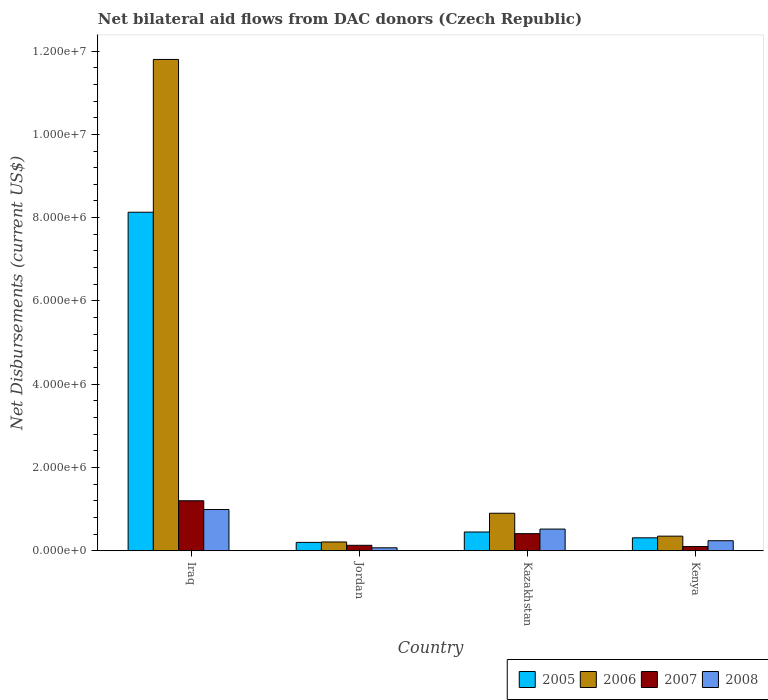How many different coloured bars are there?
Provide a short and direct response. 4. How many bars are there on the 2nd tick from the right?
Offer a terse response. 4. What is the label of the 2nd group of bars from the left?
Your response must be concise. Jordan. What is the net bilateral aid flows in 2007 in Iraq?
Offer a very short reply. 1.20e+06. Across all countries, what is the maximum net bilateral aid flows in 2007?
Offer a very short reply. 1.20e+06. In which country was the net bilateral aid flows in 2005 maximum?
Provide a succinct answer. Iraq. In which country was the net bilateral aid flows in 2005 minimum?
Make the answer very short. Jordan. What is the total net bilateral aid flows in 2007 in the graph?
Keep it short and to the point. 1.84e+06. What is the difference between the net bilateral aid flows in 2007 in Kazakhstan and that in Kenya?
Your response must be concise. 3.10e+05. What is the difference between the net bilateral aid flows in 2005 in Iraq and the net bilateral aid flows in 2006 in Kazakhstan?
Your answer should be very brief. 7.23e+06. What is the average net bilateral aid flows in 2005 per country?
Ensure brevity in your answer.  2.27e+06. What is the ratio of the net bilateral aid flows in 2006 in Jordan to that in Kenya?
Your answer should be compact. 0.6. Is the net bilateral aid flows in 2006 in Iraq less than that in Kazakhstan?
Provide a short and direct response. No. Is the difference between the net bilateral aid flows in 2005 in Iraq and Jordan greater than the difference between the net bilateral aid flows in 2008 in Iraq and Jordan?
Your response must be concise. Yes. What is the difference between the highest and the second highest net bilateral aid flows in 2005?
Your response must be concise. 7.82e+06. What is the difference between the highest and the lowest net bilateral aid flows in 2008?
Keep it short and to the point. 9.20e+05. Is it the case that in every country, the sum of the net bilateral aid flows in 2006 and net bilateral aid flows in 2007 is greater than the sum of net bilateral aid flows in 2008 and net bilateral aid flows in 2005?
Give a very brief answer. No. What does the 3rd bar from the left in Iraq represents?
Your answer should be very brief. 2007. Is it the case that in every country, the sum of the net bilateral aid flows in 2005 and net bilateral aid flows in 2008 is greater than the net bilateral aid flows in 2006?
Provide a short and direct response. No. How many bars are there?
Provide a succinct answer. 16. What is the difference between two consecutive major ticks on the Y-axis?
Keep it short and to the point. 2.00e+06. Are the values on the major ticks of Y-axis written in scientific E-notation?
Keep it short and to the point. Yes. Does the graph contain grids?
Give a very brief answer. No. How many legend labels are there?
Provide a short and direct response. 4. How are the legend labels stacked?
Provide a succinct answer. Horizontal. What is the title of the graph?
Your answer should be compact. Net bilateral aid flows from DAC donors (Czech Republic). What is the label or title of the X-axis?
Your response must be concise. Country. What is the label or title of the Y-axis?
Your answer should be very brief. Net Disbursements (current US$). What is the Net Disbursements (current US$) in 2005 in Iraq?
Your response must be concise. 8.13e+06. What is the Net Disbursements (current US$) of 2006 in Iraq?
Your response must be concise. 1.18e+07. What is the Net Disbursements (current US$) of 2007 in Iraq?
Offer a terse response. 1.20e+06. What is the Net Disbursements (current US$) of 2008 in Iraq?
Your answer should be very brief. 9.90e+05. What is the Net Disbursements (current US$) in 2006 in Jordan?
Your answer should be compact. 2.10e+05. What is the Net Disbursements (current US$) of 2007 in Jordan?
Your response must be concise. 1.30e+05. What is the Net Disbursements (current US$) in 2005 in Kazakhstan?
Offer a very short reply. 4.50e+05. What is the Net Disbursements (current US$) of 2006 in Kazakhstan?
Your answer should be very brief. 9.00e+05. What is the Net Disbursements (current US$) of 2007 in Kazakhstan?
Make the answer very short. 4.10e+05. What is the Net Disbursements (current US$) of 2008 in Kazakhstan?
Provide a short and direct response. 5.20e+05. What is the Net Disbursements (current US$) of 2005 in Kenya?
Offer a terse response. 3.10e+05. Across all countries, what is the maximum Net Disbursements (current US$) of 2005?
Ensure brevity in your answer.  8.13e+06. Across all countries, what is the maximum Net Disbursements (current US$) in 2006?
Your answer should be compact. 1.18e+07. Across all countries, what is the maximum Net Disbursements (current US$) of 2007?
Offer a terse response. 1.20e+06. Across all countries, what is the maximum Net Disbursements (current US$) of 2008?
Your response must be concise. 9.90e+05. Across all countries, what is the minimum Net Disbursements (current US$) in 2005?
Your response must be concise. 2.00e+05. Across all countries, what is the minimum Net Disbursements (current US$) of 2006?
Ensure brevity in your answer.  2.10e+05. Across all countries, what is the minimum Net Disbursements (current US$) in 2007?
Your answer should be compact. 1.00e+05. What is the total Net Disbursements (current US$) in 2005 in the graph?
Offer a very short reply. 9.09e+06. What is the total Net Disbursements (current US$) in 2006 in the graph?
Ensure brevity in your answer.  1.33e+07. What is the total Net Disbursements (current US$) of 2007 in the graph?
Give a very brief answer. 1.84e+06. What is the total Net Disbursements (current US$) in 2008 in the graph?
Make the answer very short. 1.82e+06. What is the difference between the Net Disbursements (current US$) in 2005 in Iraq and that in Jordan?
Give a very brief answer. 7.93e+06. What is the difference between the Net Disbursements (current US$) in 2006 in Iraq and that in Jordan?
Ensure brevity in your answer.  1.16e+07. What is the difference between the Net Disbursements (current US$) in 2007 in Iraq and that in Jordan?
Your answer should be very brief. 1.07e+06. What is the difference between the Net Disbursements (current US$) of 2008 in Iraq and that in Jordan?
Ensure brevity in your answer.  9.20e+05. What is the difference between the Net Disbursements (current US$) in 2005 in Iraq and that in Kazakhstan?
Your answer should be very brief. 7.68e+06. What is the difference between the Net Disbursements (current US$) in 2006 in Iraq and that in Kazakhstan?
Provide a short and direct response. 1.09e+07. What is the difference between the Net Disbursements (current US$) of 2007 in Iraq and that in Kazakhstan?
Offer a terse response. 7.90e+05. What is the difference between the Net Disbursements (current US$) in 2005 in Iraq and that in Kenya?
Make the answer very short. 7.82e+06. What is the difference between the Net Disbursements (current US$) of 2006 in Iraq and that in Kenya?
Your answer should be very brief. 1.14e+07. What is the difference between the Net Disbursements (current US$) in 2007 in Iraq and that in Kenya?
Provide a short and direct response. 1.10e+06. What is the difference between the Net Disbursements (current US$) in 2008 in Iraq and that in Kenya?
Make the answer very short. 7.50e+05. What is the difference between the Net Disbursements (current US$) in 2006 in Jordan and that in Kazakhstan?
Provide a succinct answer. -6.90e+05. What is the difference between the Net Disbursements (current US$) of 2007 in Jordan and that in Kazakhstan?
Provide a short and direct response. -2.80e+05. What is the difference between the Net Disbursements (current US$) in 2008 in Jordan and that in Kazakhstan?
Make the answer very short. -4.50e+05. What is the difference between the Net Disbursements (current US$) in 2007 in Jordan and that in Kenya?
Offer a very short reply. 3.00e+04. What is the difference between the Net Disbursements (current US$) in 2008 in Jordan and that in Kenya?
Make the answer very short. -1.70e+05. What is the difference between the Net Disbursements (current US$) of 2005 in Kazakhstan and that in Kenya?
Provide a short and direct response. 1.40e+05. What is the difference between the Net Disbursements (current US$) in 2006 in Kazakhstan and that in Kenya?
Ensure brevity in your answer.  5.50e+05. What is the difference between the Net Disbursements (current US$) of 2005 in Iraq and the Net Disbursements (current US$) of 2006 in Jordan?
Your answer should be compact. 7.92e+06. What is the difference between the Net Disbursements (current US$) in 2005 in Iraq and the Net Disbursements (current US$) in 2008 in Jordan?
Provide a short and direct response. 8.06e+06. What is the difference between the Net Disbursements (current US$) of 2006 in Iraq and the Net Disbursements (current US$) of 2007 in Jordan?
Your response must be concise. 1.17e+07. What is the difference between the Net Disbursements (current US$) in 2006 in Iraq and the Net Disbursements (current US$) in 2008 in Jordan?
Give a very brief answer. 1.17e+07. What is the difference between the Net Disbursements (current US$) in 2007 in Iraq and the Net Disbursements (current US$) in 2008 in Jordan?
Your answer should be compact. 1.13e+06. What is the difference between the Net Disbursements (current US$) of 2005 in Iraq and the Net Disbursements (current US$) of 2006 in Kazakhstan?
Make the answer very short. 7.23e+06. What is the difference between the Net Disbursements (current US$) of 2005 in Iraq and the Net Disbursements (current US$) of 2007 in Kazakhstan?
Offer a terse response. 7.72e+06. What is the difference between the Net Disbursements (current US$) in 2005 in Iraq and the Net Disbursements (current US$) in 2008 in Kazakhstan?
Offer a terse response. 7.61e+06. What is the difference between the Net Disbursements (current US$) of 2006 in Iraq and the Net Disbursements (current US$) of 2007 in Kazakhstan?
Your answer should be very brief. 1.14e+07. What is the difference between the Net Disbursements (current US$) of 2006 in Iraq and the Net Disbursements (current US$) of 2008 in Kazakhstan?
Provide a succinct answer. 1.13e+07. What is the difference between the Net Disbursements (current US$) of 2007 in Iraq and the Net Disbursements (current US$) of 2008 in Kazakhstan?
Provide a succinct answer. 6.80e+05. What is the difference between the Net Disbursements (current US$) of 2005 in Iraq and the Net Disbursements (current US$) of 2006 in Kenya?
Make the answer very short. 7.78e+06. What is the difference between the Net Disbursements (current US$) of 2005 in Iraq and the Net Disbursements (current US$) of 2007 in Kenya?
Keep it short and to the point. 8.03e+06. What is the difference between the Net Disbursements (current US$) of 2005 in Iraq and the Net Disbursements (current US$) of 2008 in Kenya?
Offer a terse response. 7.89e+06. What is the difference between the Net Disbursements (current US$) of 2006 in Iraq and the Net Disbursements (current US$) of 2007 in Kenya?
Ensure brevity in your answer.  1.17e+07. What is the difference between the Net Disbursements (current US$) in 2006 in Iraq and the Net Disbursements (current US$) in 2008 in Kenya?
Make the answer very short. 1.16e+07. What is the difference between the Net Disbursements (current US$) in 2007 in Iraq and the Net Disbursements (current US$) in 2008 in Kenya?
Your answer should be compact. 9.60e+05. What is the difference between the Net Disbursements (current US$) of 2005 in Jordan and the Net Disbursements (current US$) of 2006 in Kazakhstan?
Your answer should be very brief. -7.00e+05. What is the difference between the Net Disbursements (current US$) in 2005 in Jordan and the Net Disbursements (current US$) in 2007 in Kazakhstan?
Provide a succinct answer. -2.10e+05. What is the difference between the Net Disbursements (current US$) of 2005 in Jordan and the Net Disbursements (current US$) of 2008 in Kazakhstan?
Make the answer very short. -3.20e+05. What is the difference between the Net Disbursements (current US$) of 2006 in Jordan and the Net Disbursements (current US$) of 2007 in Kazakhstan?
Offer a very short reply. -2.00e+05. What is the difference between the Net Disbursements (current US$) in 2006 in Jordan and the Net Disbursements (current US$) in 2008 in Kazakhstan?
Offer a very short reply. -3.10e+05. What is the difference between the Net Disbursements (current US$) of 2007 in Jordan and the Net Disbursements (current US$) of 2008 in Kazakhstan?
Offer a very short reply. -3.90e+05. What is the difference between the Net Disbursements (current US$) in 2005 in Jordan and the Net Disbursements (current US$) in 2006 in Kenya?
Your response must be concise. -1.50e+05. What is the difference between the Net Disbursements (current US$) in 2005 in Jordan and the Net Disbursements (current US$) in 2007 in Kenya?
Your answer should be very brief. 1.00e+05. What is the difference between the Net Disbursements (current US$) of 2005 in Kazakhstan and the Net Disbursements (current US$) of 2008 in Kenya?
Offer a terse response. 2.10e+05. What is the difference between the Net Disbursements (current US$) of 2006 in Kazakhstan and the Net Disbursements (current US$) of 2008 in Kenya?
Your response must be concise. 6.60e+05. What is the average Net Disbursements (current US$) in 2005 per country?
Offer a terse response. 2.27e+06. What is the average Net Disbursements (current US$) in 2006 per country?
Provide a short and direct response. 3.32e+06. What is the average Net Disbursements (current US$) in 2008 per country?
Offer a terse response. 4.55e+05. What is the difference between the Net Disbursements (current US$) of 2005 and Net Disbursements (current US$) of 2006 in Iraq?
Give a very brief answer. -3.67e+06. What is the difference between the Net Disbursements (current US$) of 2005 and Net Disbursements (current US$) of 2007 in Iraq?
Offer a terse response. 6.93e+06. What is the difference between the Net Disbursements (current US$) of 2005 and Net Disbursements (current US$) of 2008 in Iraq?
Ensure brevity in your answer.  7.14e+06. What is the difference between the Net Disbursements (current US$) of 2006 and Net Disbursements (current US$) of 2007 in Iraq?
Give a very brief answer. 1.06e+07. What is the difference between the Net Disbursements (current US$) of 2006 and Net Disbursements (current US$) of 2008 in Iraq?
Your response must be concise. 1.08e+07. What is the difference between the Net Disbursements (current US$) in 2007 and Net Disbursements (current US$) in 2008 in Iraq?
Give a very brief answer. 2.10e+05. What is the difference between the Net Disbursements (current US$) of 2005 and Net Disbursements (current US$) of 2008 in Jordan?
Offer a terse response. 1.30e+05. What is the difference between the Net Disbursements (current US$) in 2006 and Net Disbursements (current US$) in 2008 in Jordan?
Keep it short and to the point. 1.40e+05. What is the difference between the Net Disbursements (current US$) in 2005 and Net Disbursements (current US$) in 2006 in Kazakhstan?
Provide a short and direct response. -4.50e+05. What is the difference between the Net Disbursements (current US$) in 2005 and Net Disbursements (current US$) in 2007 in Kazakhstan?
Your response must be concise. 4.00e+04. What is the difference between the Net Disbursements (current US$) of 2006 and Net Disbursements (current US$) of 2007 in Kazakhstan?
Your answer should be very brief. 4.90e+05. What is the difference between the Net Disbursements (current US$) in 2007 and Net Disbursements (current US$) in 2008 in Kazakhstan?
Ensure brevity in your answer.  -1.10e+05. What is the difference between the Net Disbursements (current US$) in 2005 and Net Disbursements (current US$) in 2007 in Kenya?
Your answer should be very brief. 2.10e+05. What is the difference between the Net Disbursements (current US$) in 2005 and Net Disbursements (current US$) in 2008 in Kenya?
Give a very brief answer. 7.00e+04. What is the difference between the Net Disbursements (current US$) of 2006 and Net Disbursements (current US$) of 2008 in Kenya?
Give a very brief answer. 1.10e+05. What is the difference between the Net Disbursements (current US$) of 2007 and Net Disbursements (current US$) of 2008 in Kenya?
Give a very brief answer. -1.40e+05. What is the ratio of the Net Disbursements (current US$) of 2005 in Iraq to that in Jordan?
Provide a succinct answer. 40.65. What is the ratio of the Net Disbursements (current US$) of 2006 in Iraq to that in Jordan?
Give a very brief answer. 56.19. What is the ratio of the Net Disbursements (current US$) in 2007 in Iraq to that in Jordan?
Your response must be concise. 9.23. What is the ratio of the Net Disbursements (current US$) of 2008 in Iraq to that in Jordan?
Offer a terse response. 14.14. What is the ratio of the Net Disbursements (current US$) in 2005 in Iraq to that in Kazakhstan?
Provide a succinct answer. 18.07. What is the ratio of the Net Disbursements (current US$) in 2006 in Iraq to that in Kazakhstan?
Your answer should be very brief. 13.11. What is the ratio of the Net Disbursements (current US$) in 2007 in Iraq to that in Kazakhstan?
Your response must be concise. 2.93. What is the ratio of the Net Disbursements (current US$) in 2008 in Iraq to that in Kazakhstan?
Keep it short and to the point. 1.9. What is the ratio of the Net Disbursements (current US$) in 2005 in Iraq to that in Kenya?
Give a very brief answer. 26.23. What is the ratio of the Net Disbursements (current US$) in 2006 in Iraq to that in Kenya?
Offer a terse response. 33.71. What is the ratio of the Net Disbursements (current US$) of 2008 in Iraq to that in Kenya?
Give a very brief answer. 4.12. What is the ratio of the Net Disbursements (current US$) in 2005 in Jordan to that in Kazakhstan?
Your answer should be compact. 0.44. What is the ratio of the Net Disbursements (current US$) in 2006 in Jordan to that in Kazakhstan?
Offer a very short reply. 0.23. What is the ratio of the Net Disbursements (current US$) in 2007 in Jordan to that in Kazakhstan?
Keep it short and to the point. 0.32. What is the ratio of the Net Disbursements (current US$) of 2008 in Jordan to that in Kazakhstan?
Your answer should be very brief. 0.13. What is the ratio of the Net Disbursements (current US$) in 2005 in Jordan to that in Kenya?
Your response must be concise. 0.65. What is the ratio of the Net Disbursements (current US$) of 2007 in Jordan to that in Kenya?
Offer a terse response. 1.3. What is the ratio of the Net Disbursements (current US$) in 2008 in Jordan to that in Kenya?
Your answer should be very brief. 0.29. What is the ratio of the Net Disbursements (current US$) in 2005 in Kazakhstan to that in Kenya?
Offer a very short reply. 1.45. What is the ratio of the Net Disbursements (current US$) in 2006 in Kazakhstan to that in Kenya?
Keep it short and to the point. 2.57. What is the ratio of the Net Disbursements (current US$) of 2007 in Kazakhstan to that in Kenya?
Provide a succinct answer. 4.1. What is the ratio of the Net Disbursements (current US$) of 2008 in Kazakhstan to that in Kenya?
Make the answer very short. 2.17. What is the difference between the highest and the second highest Net Disbursements (current US$) of 2005?
Keep it short and to the point. 7.68e+06. What is the difference between the highest and the second highest Net Disbursements (current US$) in 2006?
Ensure brevity in your answer.  1.09e+07. What is the difference between the highest and the second highest Net Disbursements (current US$) of 2007?
Give a very brief answer. 7.90e+05. What is the difference between the highest and the lowest Net Disbursements (current US$) of 2005?
Your response must be concise. 7.93e+06. What is the difference between the highest and the lowest Net Disbursements (current US$) of 2006?
Provide a short and direct response. 1.16e+07. What is the difference between the highest and the lowest Net Disbursements (current US$) of 2007?
Make the answer very short. 1.10e+06. What is the difference between the highest and the lowest Net Disbursements (current US$) in 2008?
Your answer should be compact. 9.20e+05. 